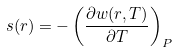<formula> <loc_0><loc_0><loc_500><loc_500>s ( r ) = - \left ( \frac { \partial w ( r , T ) } { \partial T } \right ) _ { P }</formula> 